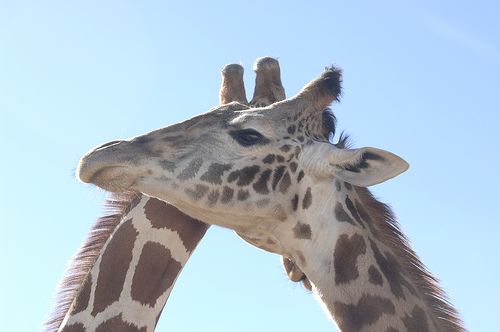<image>
Is there a brown spot in front of the open space? No. The brown spot is not in front of the open space. The spatial positioning shows a different relationship between these objects. 